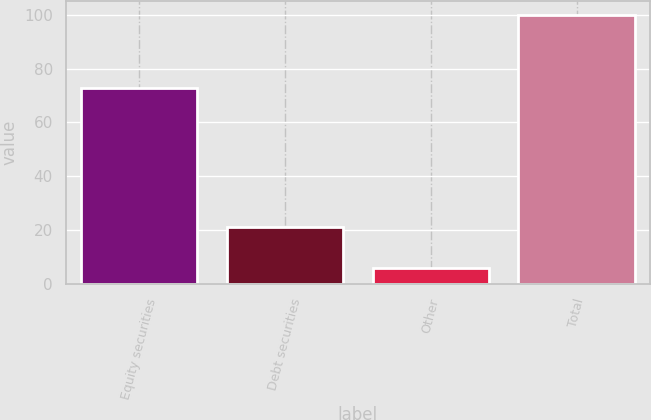Convert chart. <chart><loc_0><loc_0><loc_500><loc_500><bar_chart><fcel>Equity securities<fcel>Debt securities<fcel>Other<fcel>Total<nl><fcel>73<fcel>21<fcel>6<fcel>100<nl></chart> 